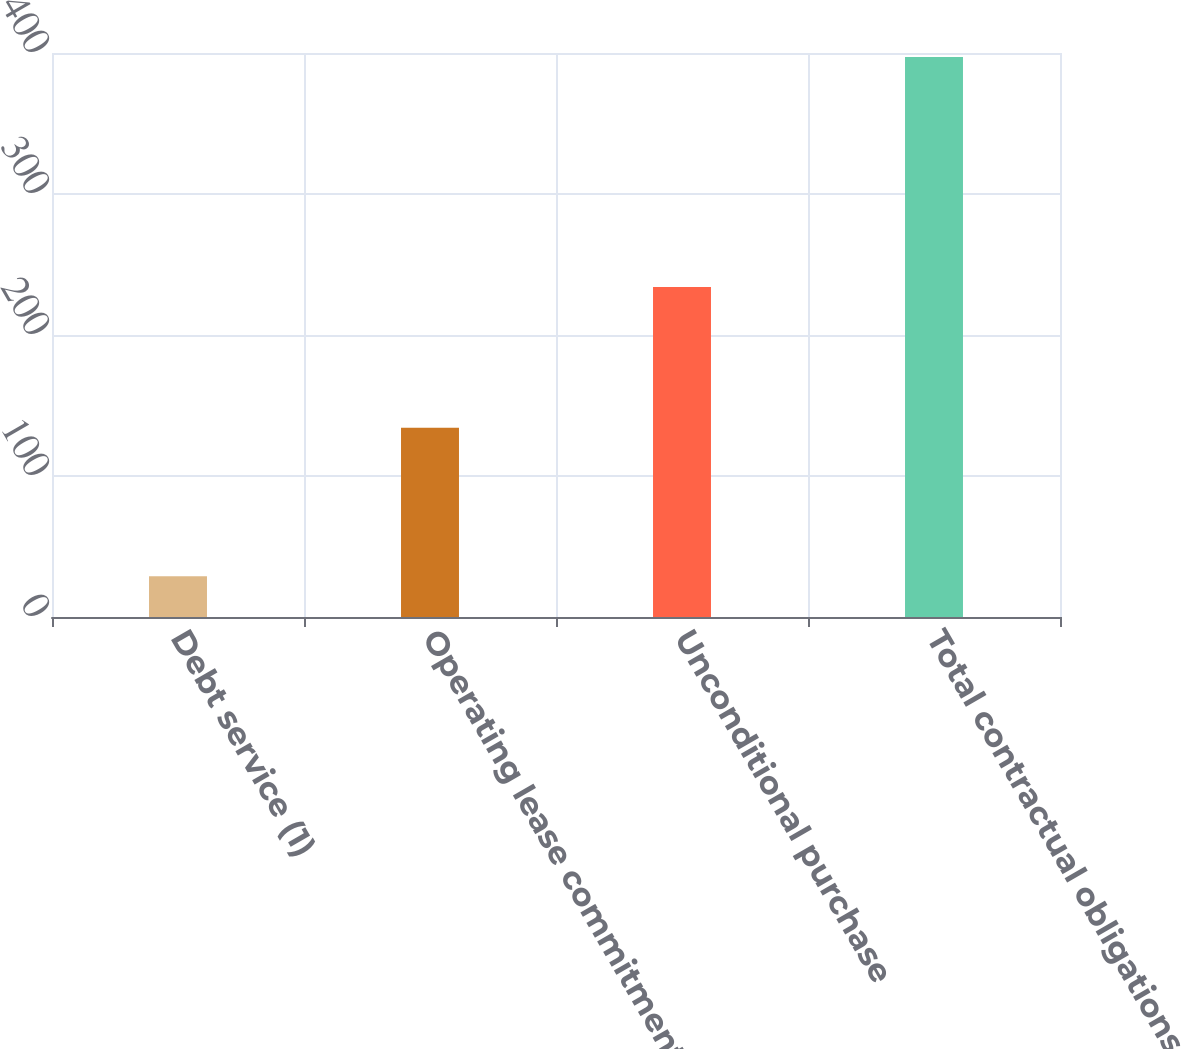<chart> <loc_0><loc_0><loc_500><loc_500><bar_chart><fcel>Debt service (1)<fcel>Operating lease commitments<fcel>Unconditional purchase<fcel>Total contractual obligations<nl><fcel>28.9<fcel>134.2<fcel>234<fcel>397.1<nl></chart> 